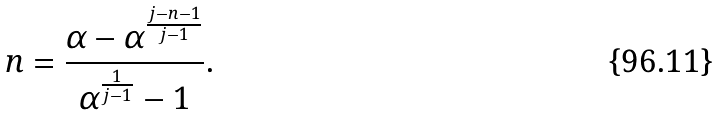<formula> <loc_0><loc_0><loc_500><loc_500>n = \frac { \alpha - \alpha ^ { \frac { j - n - 1 } { j - 1 } } } { \alpha ^ { \frac { 1 } { j - 1 } } - 1 } .</formula> 